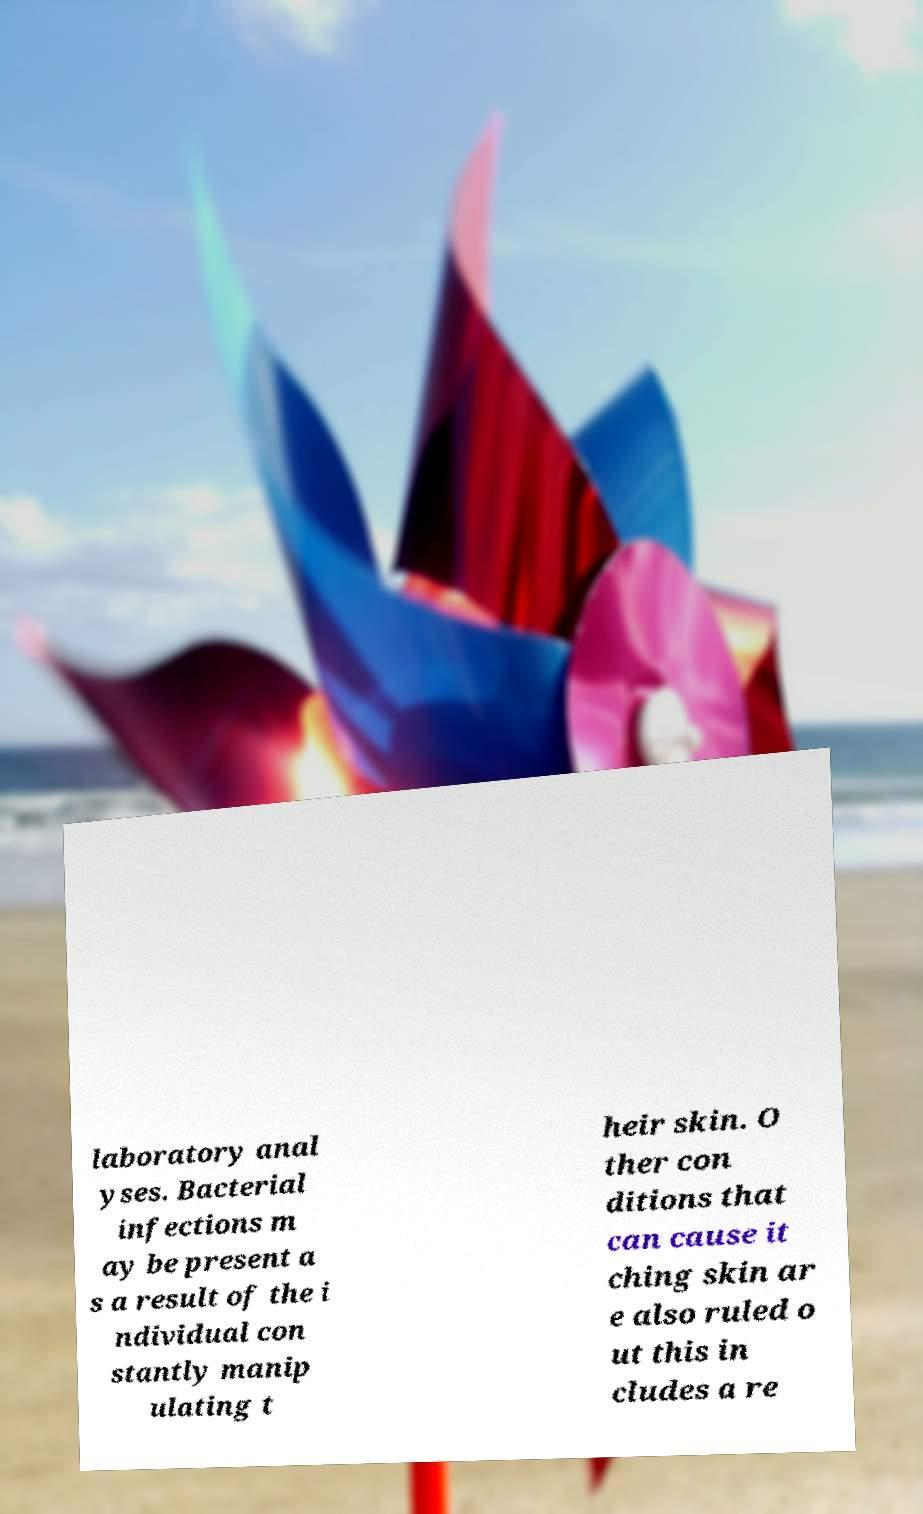Could you assist in decoding the text presented in this image and type it out clearly? laboratory anal yses. Bacterial infections m ay be present a s a result of the i ndividual con stantly manip ulating t heir skin. O ther con ditions that can cause it ching skin ar e also ruled o ut this in cludes a re 